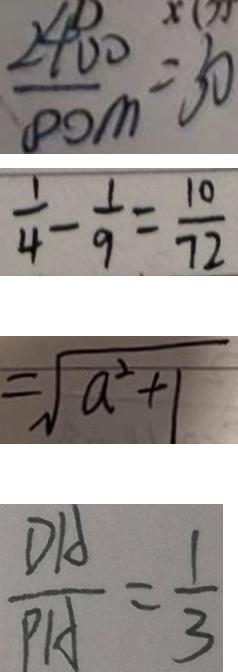<formula> <loc_0><loc_0><loc_500><loc_500>\frac { 2 4 0 0 } { 8 0 m } = 3 0 
 \frac { 1 } { 4 } - \frac { 1 } { 9 } = \frac { 1 0 } { 7 2 } 
 = \sqrt { a ^ { 2 } + 1 } 
 \frac { D A } { P A } = \frac { 1 } { 3 }</formula> 